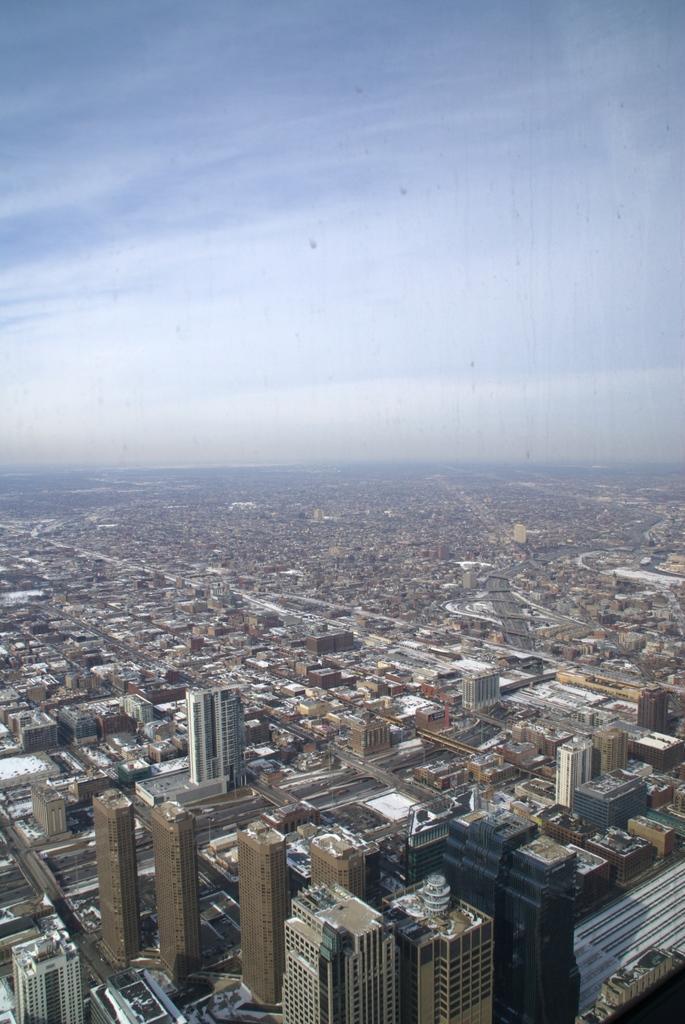Could you give a brief overview of what you see in this image? In this picture we can see the top view of the city. In the front we can see the many buildings and on the top there is a sky. 